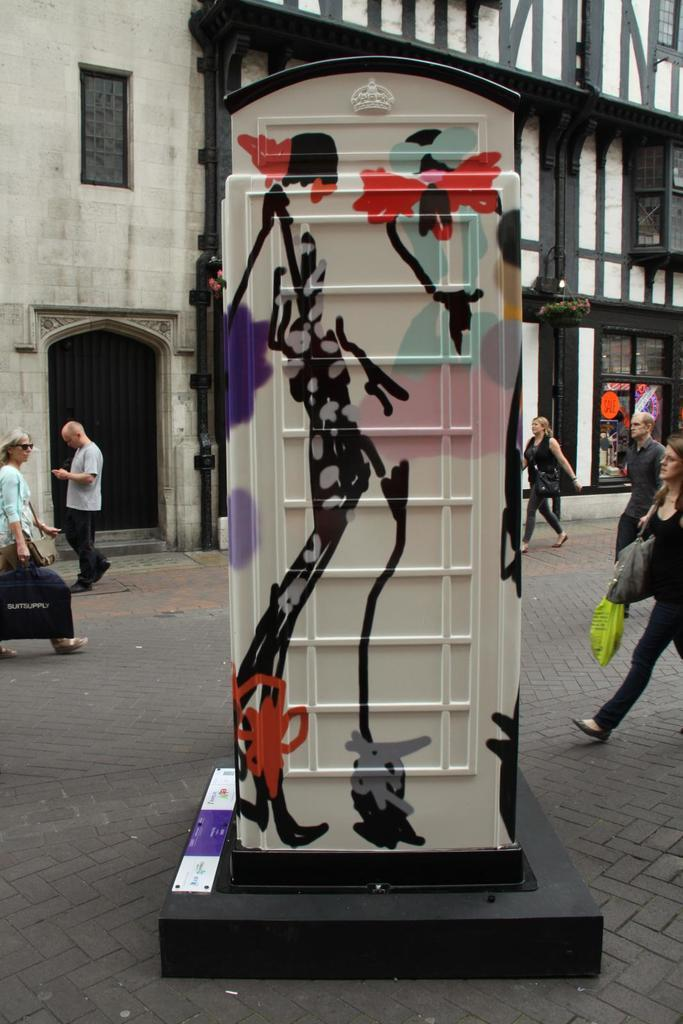What type of furniture is present in the image? There is a toilet cabinet in the image. Can you describe the people in the image? There is a group of people standing in the image. What type of structure is visible in the image? There is a building in the image. What type of pet can be seen playing with a clover in the image? There is no pet or clover present in the image. 